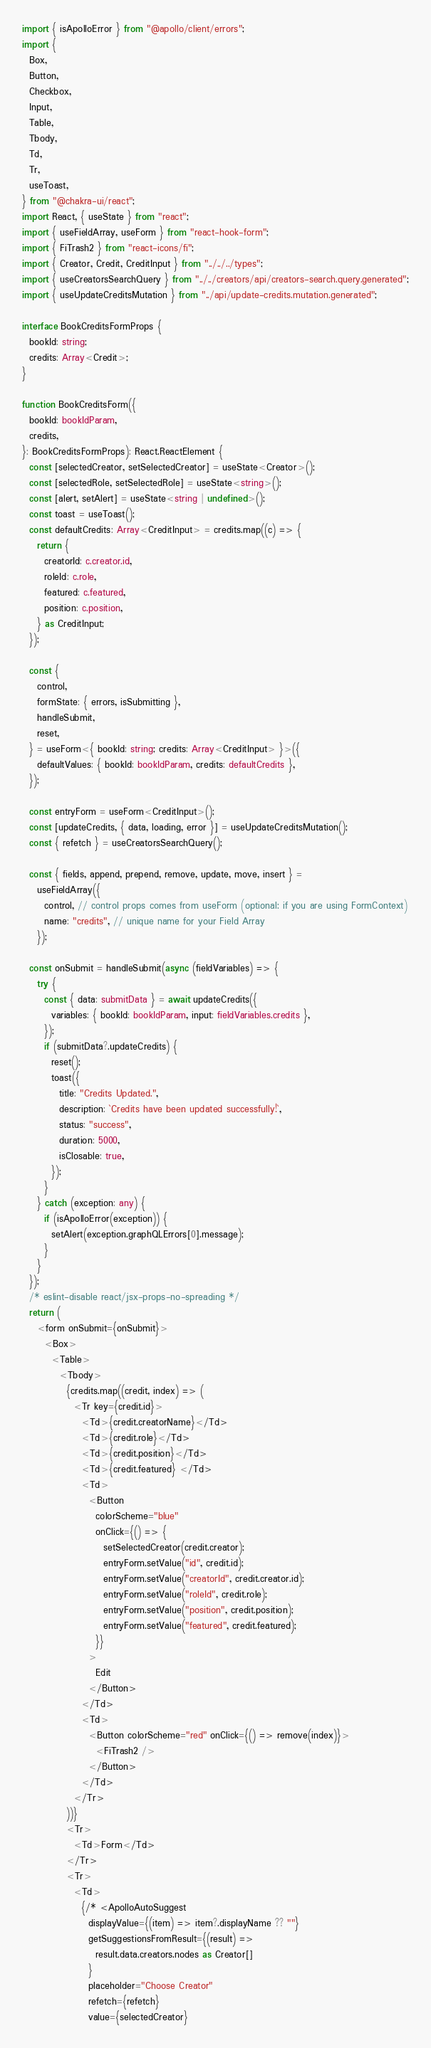Convert code to text. <code><loc_0><loc_0><loc_500><loc_500><_TypeScript_>import { isApolloError } from "@apollo/client/errors";
import {
  Box,
  Button,
  Checkbox,
  Input,
  Table,
  Tbody,
  Td,
  Tr,
  useToast,
} from "@chakra-ui/react";
import React, { useState } from "react";
import { useFieldArray, useForm } from "react-hook-form";
import { FiTrash2 } from "react-icons/fi";
import { Creator, Credit, CreditInput } from "../../../types";
import { useCreatorsSearchQuery } from "../../creators/api/creators-search.query.generated";
import { useUpdateCreditsMutation } from "../api/update-credits.mutation.generated";

interface BookCreditsFormProps {
  bookId: string;
  credits: Array<Credit>;
}

function BookCreditsForm({
  bookId: bookIdParam,
  credits,
}: BookCreditsFormProps): React.ReactElement {
  const [selectedCreator, setSelectedCreator] = useState<Creator>();
  const [selectedRole, setSelectedRole] = useState<string>();
  const [alert, setAlert] = useState<string | undefined>();
  const toast = useToast();
  const defaultCredits: Array<CreditInput> = credits.map((c) => {
    return {
      creatorId: c.creator.id,
      roleId: c.role,
      featured: c.featured,
      position: c.position,
    } as CreditInput;
  });

  const {
    control,
    formState: { errors, isSubmitting },
    handleSubmit,
    reset,
  } = useForm<{ bookId: string; credits: Array<CreditInput> }>({
    defaultValues: { bookId: bookIdParam, credits: defaultCredits },
  });

  const entryForm = useForm<CreditInput>();
  const [updateCredits, { data, loading, error }] = useUpdateCreditsMutation();
  const { refetch } = useCreatorsSearchQuery();

  const { fields, append, prepend, remove, update, move, insert } =
    useFieldArray({
      control, // control props comes from useForm (optional: if you are using FormContext)
      name: "credits", // unique name for your Field Array
    });

  const onSubmit = handleSubmit(async (fieldVariables) => {
    try {
      const { data: submitData } = await updateCredits({
        variables: { bookId: bookIdParam, input: fieldVariables.credits },
      });
      if (submitData?.updateCredits) {
        reset();
        toast({
          title: "Credits Updated.",
          description: `Credits have been updated successfully!`,
          status: "success",
          duration: 5000,
          isClosable: true,
        });
      }
    } catch (exception: any) {
      if (isApolloError(exception)) {
        setAlert(exception.graphQLErrors[0].message);
      }
    }
  });
  /* eslint-disable react/jsx-props-no-spreading */
  return (
    <form onSubmit={onSubmit}>
      <Box>
        <Table>
          <Tbody>
            {credits.map((credit, index) => (
              <Tr key={credit.id}>
                <Td>{credit.creatorName}</Td>
                <Td>{credit.role}</Td>
                <Td>{credit.position}</Td>
                <Td>{credit.featured} </Td>
                <Td>
                  <Button
                    colorScheme="blue"
                    onClick={() => {
                      setSelectedCreator(credit.creator);
                      entryForm.setValue("id", credit.id);
                      entryForm.setValue("creatorId", credit.creator.id);
                      entryForm.setValue("roleId", credit.role);
                      entryForm.setValue("position", credit.position);
                      entryForm.setValue("featured", credit.featured);
                    }}
                  >
                    Edit
                  </Button>
                </Td>
                <Td>
                  <Button colorScheme="red" onClick={() => remove(index)}>
                    <FiTrash2 />
                  </Button>
                </Td>
              </Tr>
            ))}
            <Tr>
              <Td>Form</Td>
            </Tr>
            <Tr>
              <Td>
                {/* <ApolloAutoSuggest
                  displayValue={(item) => item?.displayName ?? ""}
                  getSuggestionsFromResult={(result) =>
                    result.data.creators.nodes as Creator[]
                  }
                  placeholder="Choose Creator"
                  refetch={refetch}
                  value={selectedCreator}</code> 